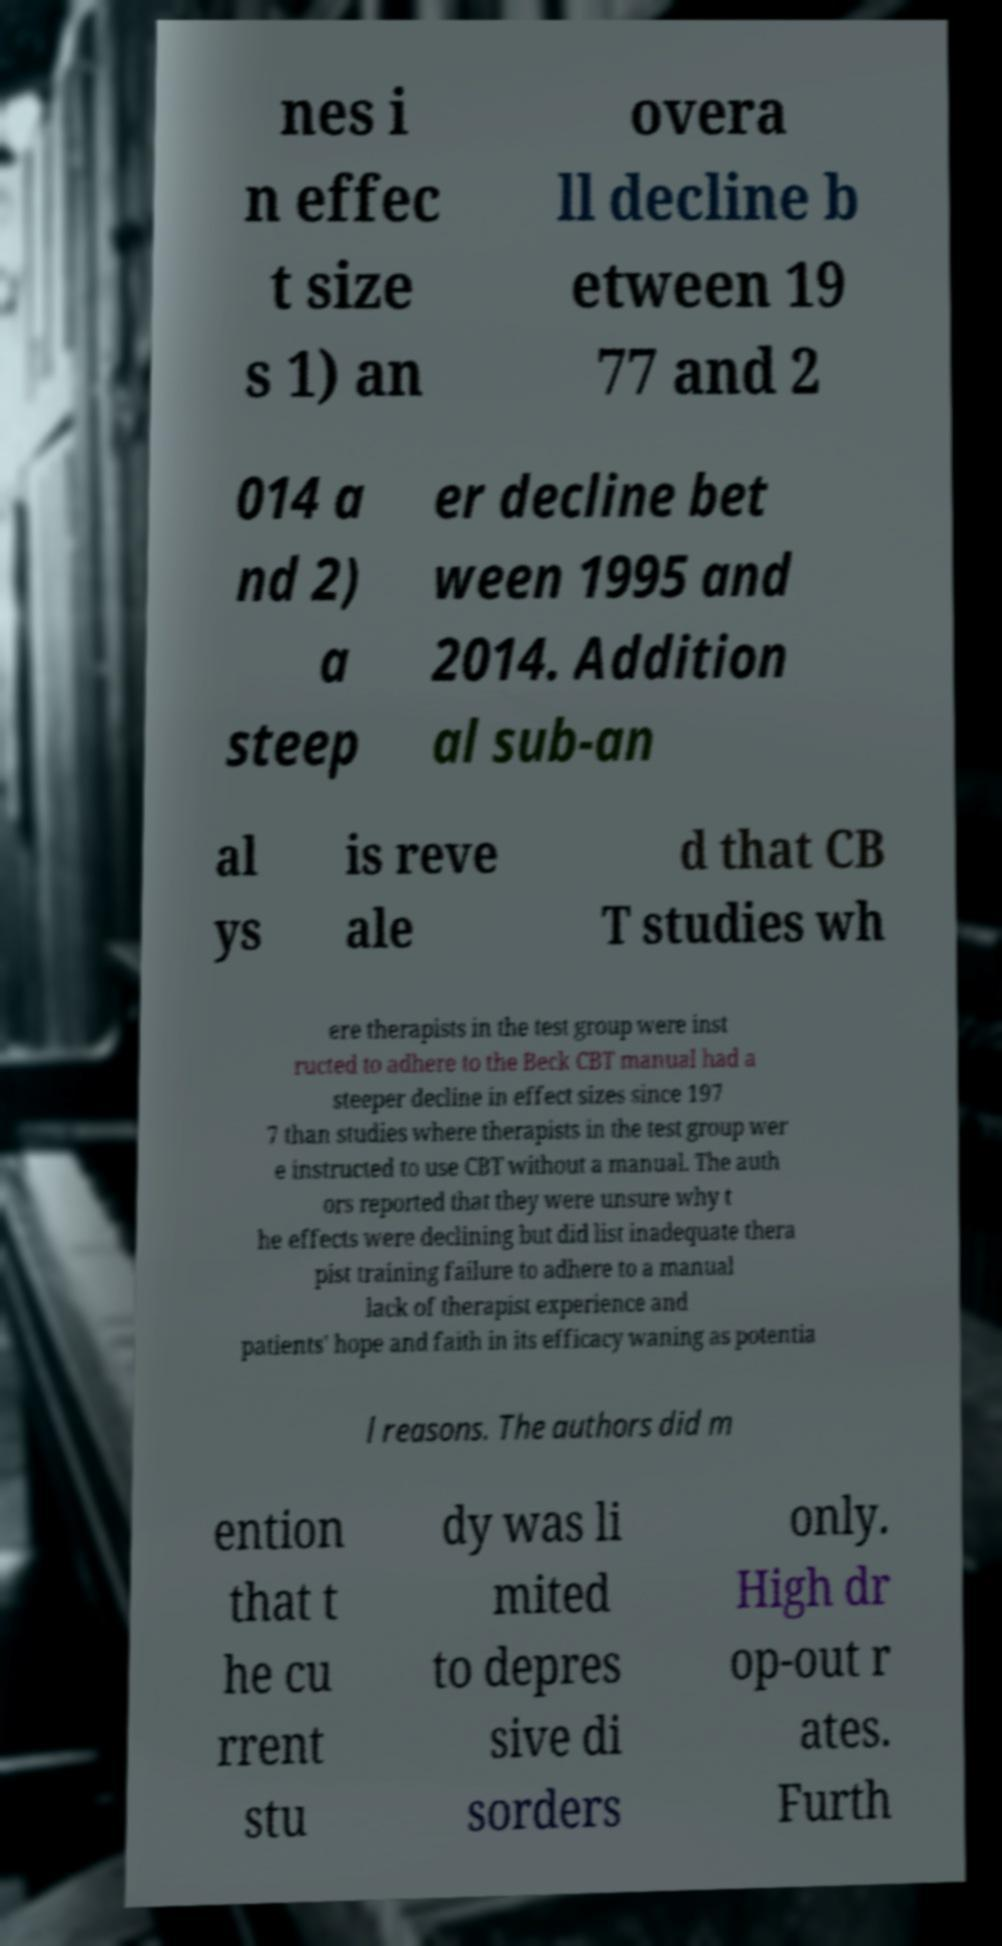Can you accurately transcribe the text from the provided image for me? nes i n effec t size s 1) an overa ll decline b etween 19 77 and 2 014 a nd 2) a steep er decline bet ween 1995 and 2014. Addition al sub-an al ys is reve ale d that CB T studies wh ere therapists in the test group were inst ructed to adhere to the Beck CBT manual had a steeper decline in effect sizes since 197 7 than studies where therapists in the test group wer e instructed to use CBT without a manual. The auth ors reported that they were unsure why t he effects were declining but did list inadequate thera pist training failure to adhere to a manual lack of therapist experience and patients' hope and faith in its efficacy waning as potentia l reasons. The authors did m ention that t he cu rrent stu dy was li mited to depres sive di sorders only. High dr op-out r ates. Furth 